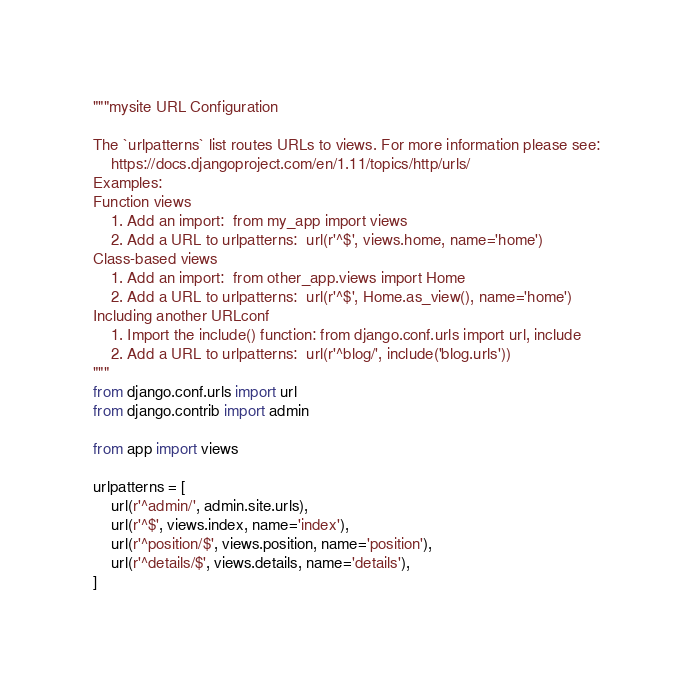<code> <loc_0><loc_0><loc_500><loc_500><_Python_>"""mysite URL Configuration

The `urlpatterns` list routes URLs to views. For more information please see:
    https://docs.djangoproject.com/en/1.11/topics/http/urls/
Examples:
Function views
    1. Add an import:  from my_app import views
    2. Add a URL to urlpatterns:  url(r'^$', views.home, name='home')
Class-based views
    1. Add an import:  from other_app.views import Home
    2. Add a URL to urlpatterns:  url(r'^$', Home.as_view(), name='home')
Including another URLconf
    1. Import the include() function: from django.conf.urls import url, include
    2. Add a URL to urlpatterns:  url(r'^blog/', include('blog.urls'))
"""
from django.conf.urls import url
from django.contrib import admin

from app import views

urlpatterns = [
    url(r'^admin/', admin.site.urls),
    url(r'^$', views.index, name='index'),
    url(r'^position/$', views.position, name='position'),
    url(r'^details/$', views.details, name='details'),
]
</code> 